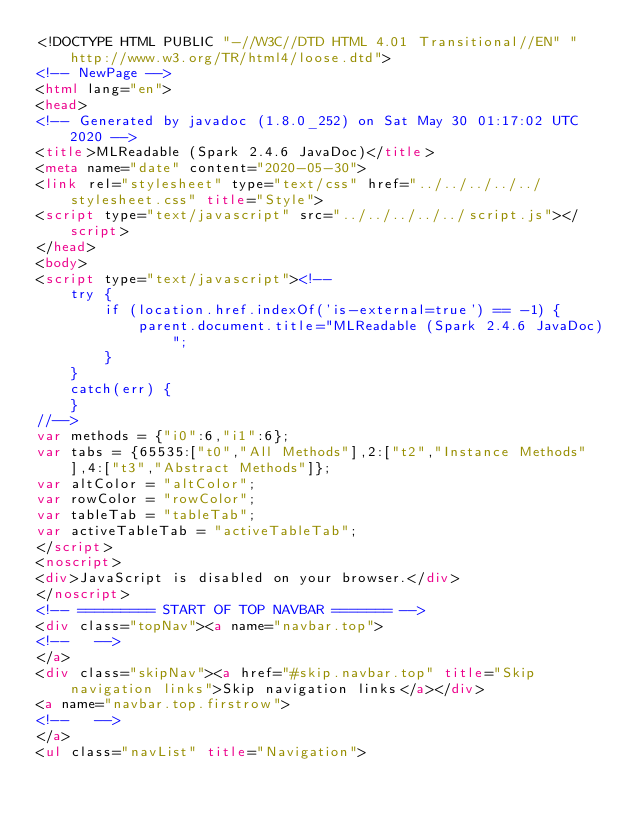Convert code to text. <code><loc_0><loc_0><loc_500><loc_500><_HTML_><!DOCTYPE HTML PUBLIC "-//W3C//DTD HTML 4.01 Transitional//EN" "http://www.w3.org/TR/html4/loose.dtd">
<!-- NewPage -->
<html lang="en">
<head>
<!-- Generated by javadoc (1.8.0_252) on Sat May 30 01:17:02 UTC 2020 -->
<title>MLReadable (Spark 2.4.6 JavaDoc)</title>
<meta name="date" content="2020-05-30">
<link rel="stylesheet" type="text/css" href="../../../../../stylesheet.css" title="Style">
<script type="text/javascript" src="../../../../../script.js"></script>
</head>
<body>
<script type="text/javascript"><!--
    try {
        if (location.href.indexOf('is-external=true') == -1) {
            parent.document.title="MLReadable (Spark 2.4.6 JavaDoc)";
        }
    }
    catch(err) {
    }
//-->
var methods = {"i0":6,"i1":6};
var tabs = {65535:["t0","All Methods"],2:["t2","Instance Methods"],4:["t3","Abstract Methods"]};
var altColor = "altColor";
var rowColor = "rowColor";
var tableTab = "tableTab";
var activeTableTab = "activeTableTab";
</script>
<noscript>
<div>JavaScript is disabled on your browser.</div>
</noscript>
<!-- ========= START OF TOP NAVBAR ======= -->
<div class="topNav"><a name="navbar.top">
<!--   -->
</a>
<div class="skipNav"><a href="#skip.navbar.top" title="Skip navigation links">Skip navigation links</a></div>
<a name="navbar.top.firstrow">
<!--   -->
</a>
<ul class="navList" title="Navigation"></code> 